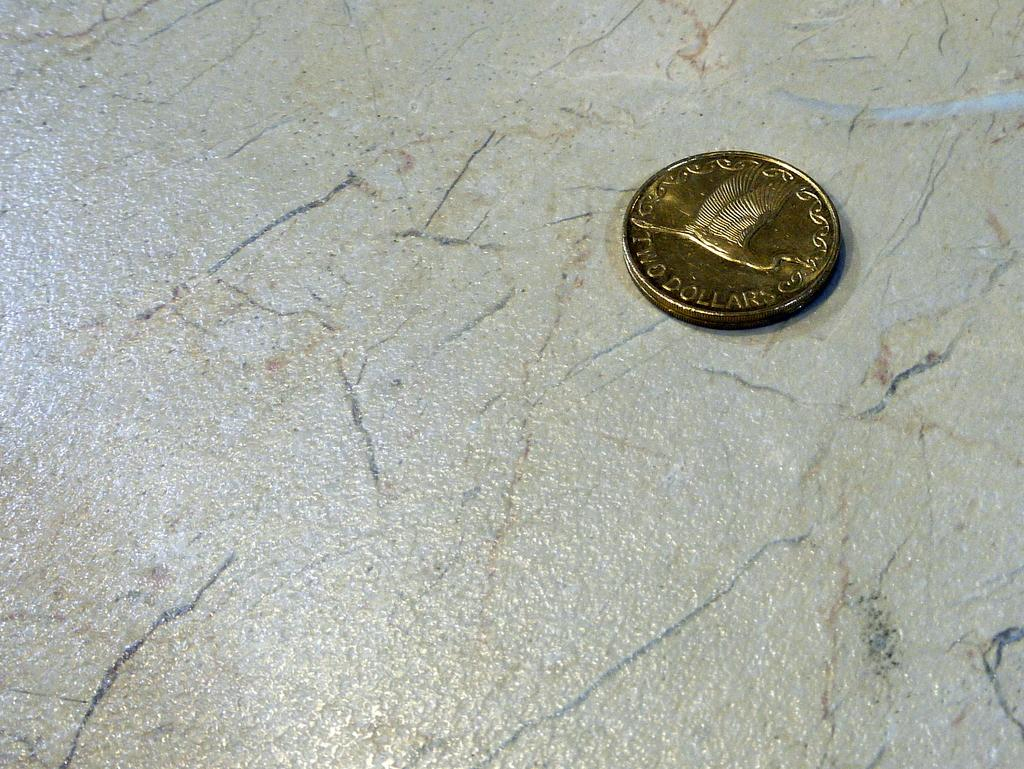What object is present on a surface in the image? There is a coin in the image. Can you describe the position of the coin in the image? The coin is kept on a surface in the image. What type of house is depicted in the image? There is no house present in the image; it only features a coin on a surface. What role does the glue play in the image? There is no glue present in the image. 